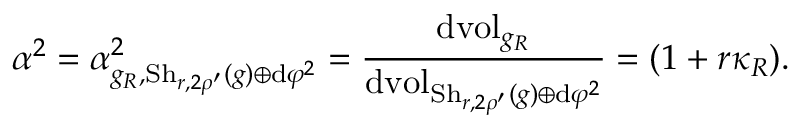<formula> <loc_0><loc_0><loc_500><loc_500>\alpha ^ { 2 } = \alpha _ { g _ { R } , S h _ { r , 2 \rho ^ { \prime } } ( g ) \oplus d \varphi ^ { 2 } } ^ { 2 } = \frac { d v o l _ { g _ { R } } } { d v o l _ { S h _ { r , 2 \rho ^ { \prime } } ( g ) \oplus d \varphi ^ { 2 } } } = ( 1 + r \kappa _ { R } ) .</formula> 